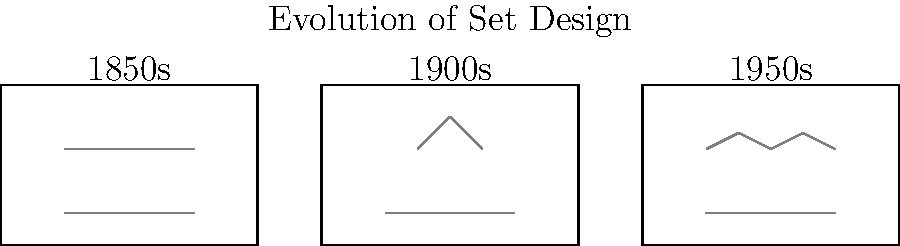Analyze the sketches depicting the evolution of theatrical set designs from the 1850s to the 1950s. How do these changes reflect the impact of industrialization on local communities, and what challenges might an aspiring playwright face when incorporating these evolving set designs into a community-focused narrative? 1. 1850s Set Design:
   - Simple, linear design with horizontal lines
   - Represents pre-industrial, agrarian society
   - Minimal complexity, focus on dialogue and character interaction

2. 1900s Set Design:
   - Introduction of angular shapes (factory outline)
   - Represents early industrialization
   - Challenges: Balancing traditional community values with industrial progress

3. 1950s Set Design:
   - Complex, interconnected machinery shapes
   - Represents advanced industrialization and mechanization
   - Challenges: Depicting the impact of rapid technological change on community dynamics

4. Overall Evolution:
   - Increasing complexity and abstraction in set designs
   - Reflects the transformation of society from rural to industrial
   - Symbolizes the changing landscape of communities

5. Playwright Challenges:
   - Integrating evolving set designs while maintaining focus on community stories
   - Balancing visual representation of industrialization with character development
   - Using set design to enhance, not overshadow, the narrative of community impact

6. Opportunities for Playwrights:
   - Utilizing set design to create a visual metaphor for societal changes
   - Exploring the tension between tradition and progress through visual elements
   - Engaging audiences with a multi-sensory experience of industrialization's impact
Answer: Set designs evolve from simple linear forms to complex machinery, reflecting industrialization's impact on communities and challenging playwrights to balance visual representation with character-driven narratives. 